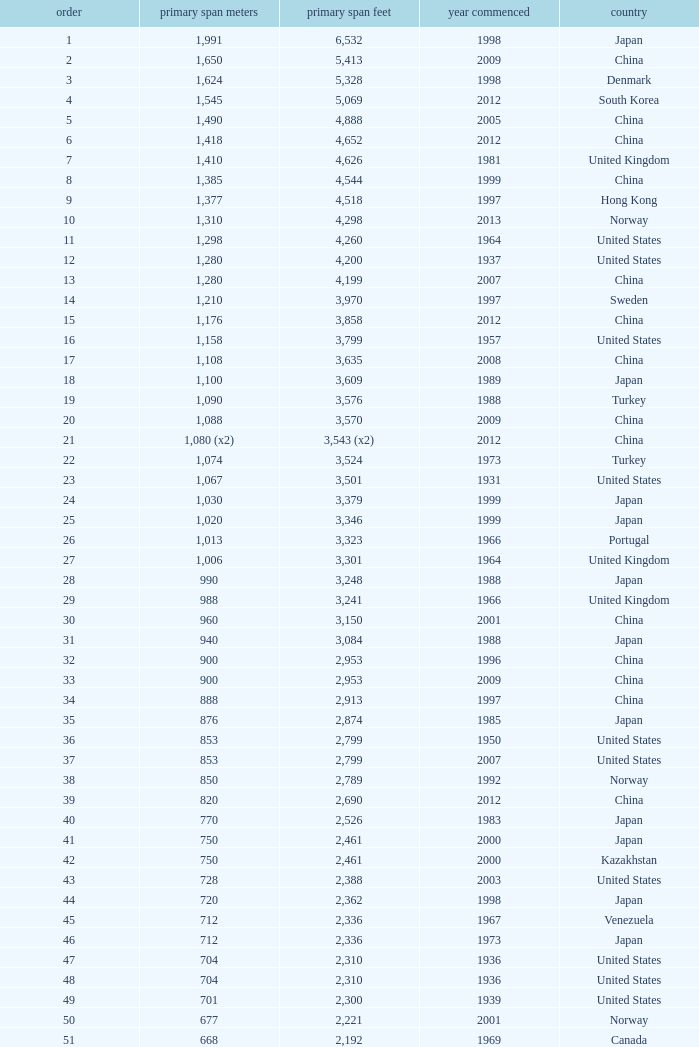What is the oldest year with a main span feet of 1,640 in South Korea? 2002.0. 